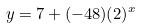Convert formula to latex. <formula><loc_0><loc_0><loc_500><loc_500>y = 7 + ( - 4 8 ) ( 2 ) ^ { x }</formula> 